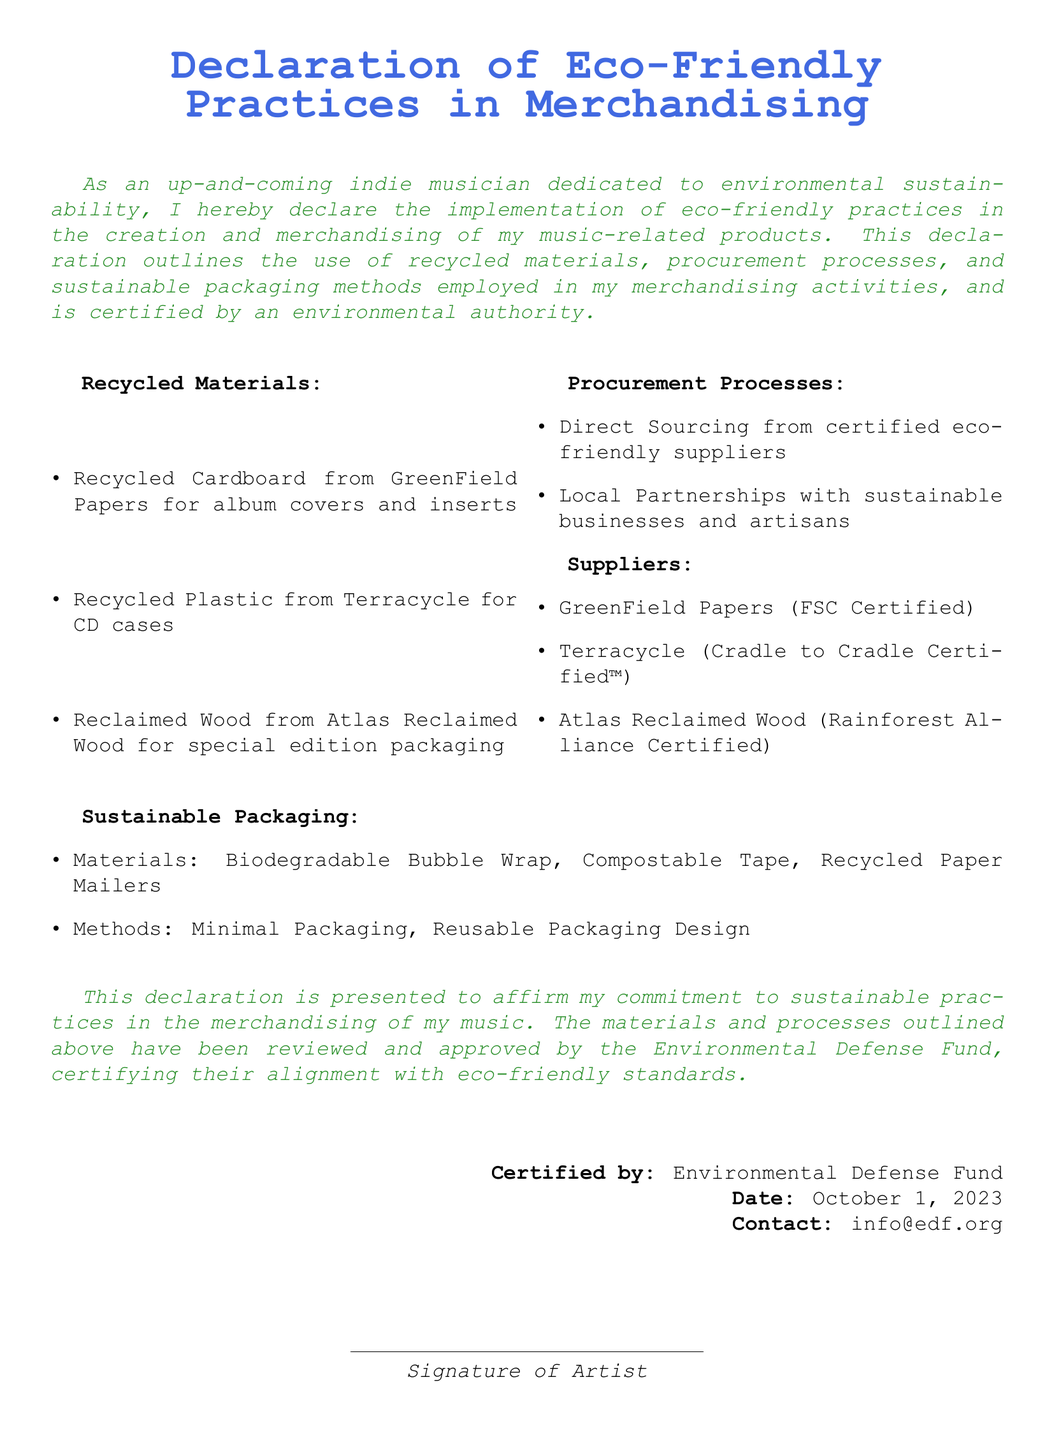What is the title of the document? The title is prominently displayed at the center of the document, indicating its purpose.
Answer: Declaration of Eco-Friendly Practices in Merchandising Who certified the eco-friendly practices? The certification authority is specified at the end of the document, affirming validation of the practices.
Answer: Environmental Defense Fund What date was the declaration certified? The certification date is noted in the document, confirming when it was approved.
Answer: October 1, 2023 What type of recycled material is used for album covers? This information can be found in the section detailing recycled materials used in merchandising.
Answer: Recycled Cardboard from GreenField Papers What is one method of sustainable packaging mentioned? The document lists various methods under sustainable packaging practices.
Answer: Minimal Packaging Which company provides recycled plastic for CD cases? This detail is mentioned explicitly in the list of recycled materials.
Answer: Terracycle What is a key procurement process used in merchandising? This detail highlights an essential strategy employed in obtaining materials sustainably.
Answer: Direct Sourcing from certified eco-friendly suppliers What type of tape is used in sustainable packaging? This is specified in the sustainable packaging section discussing materials.
Answer: Compostable Tape 